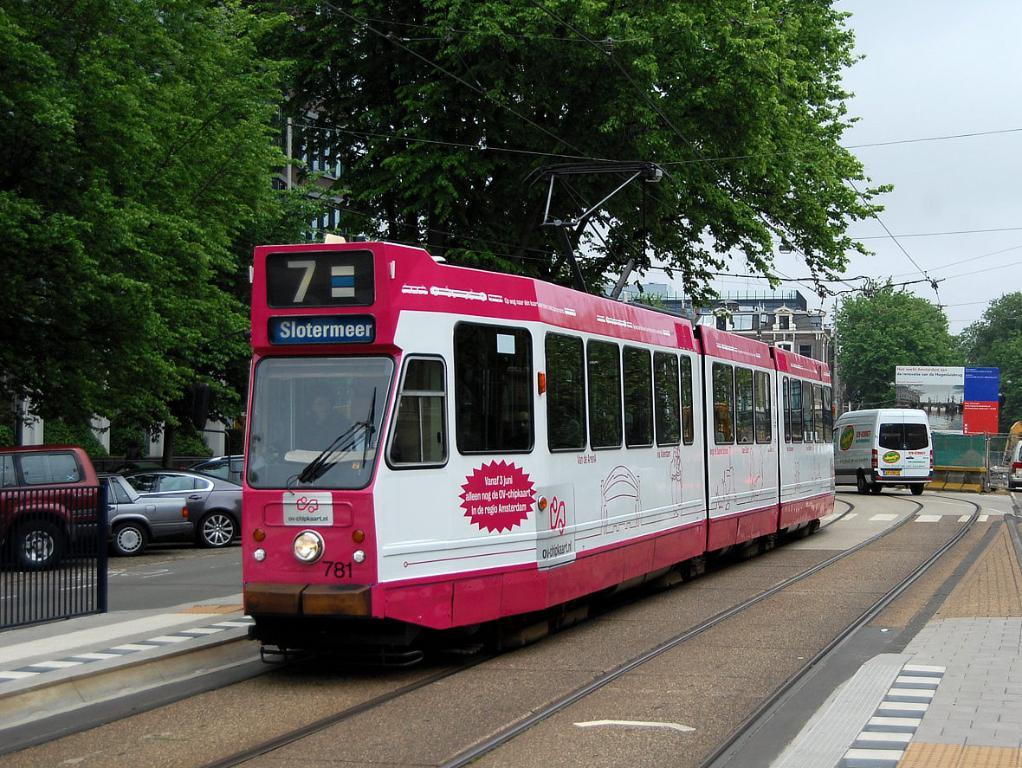<image>
Describe the image concisely. the number 7b on top of a large bus 